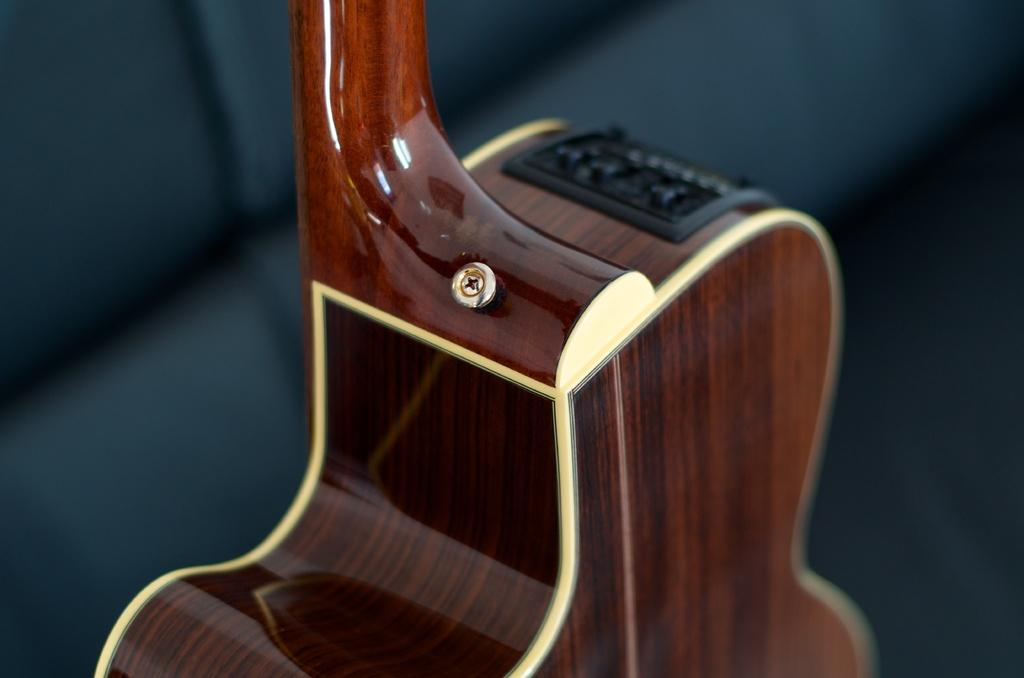What musical instrument is present in the image? There is a guitar in the image. What is the color of the guitar? The guitar is brown in color. What material is the guitar made of? The guitar is made of wood. What type of brass instrument is present in the image? There is no brass instrument present in the image; it features a guitar made of wood. 